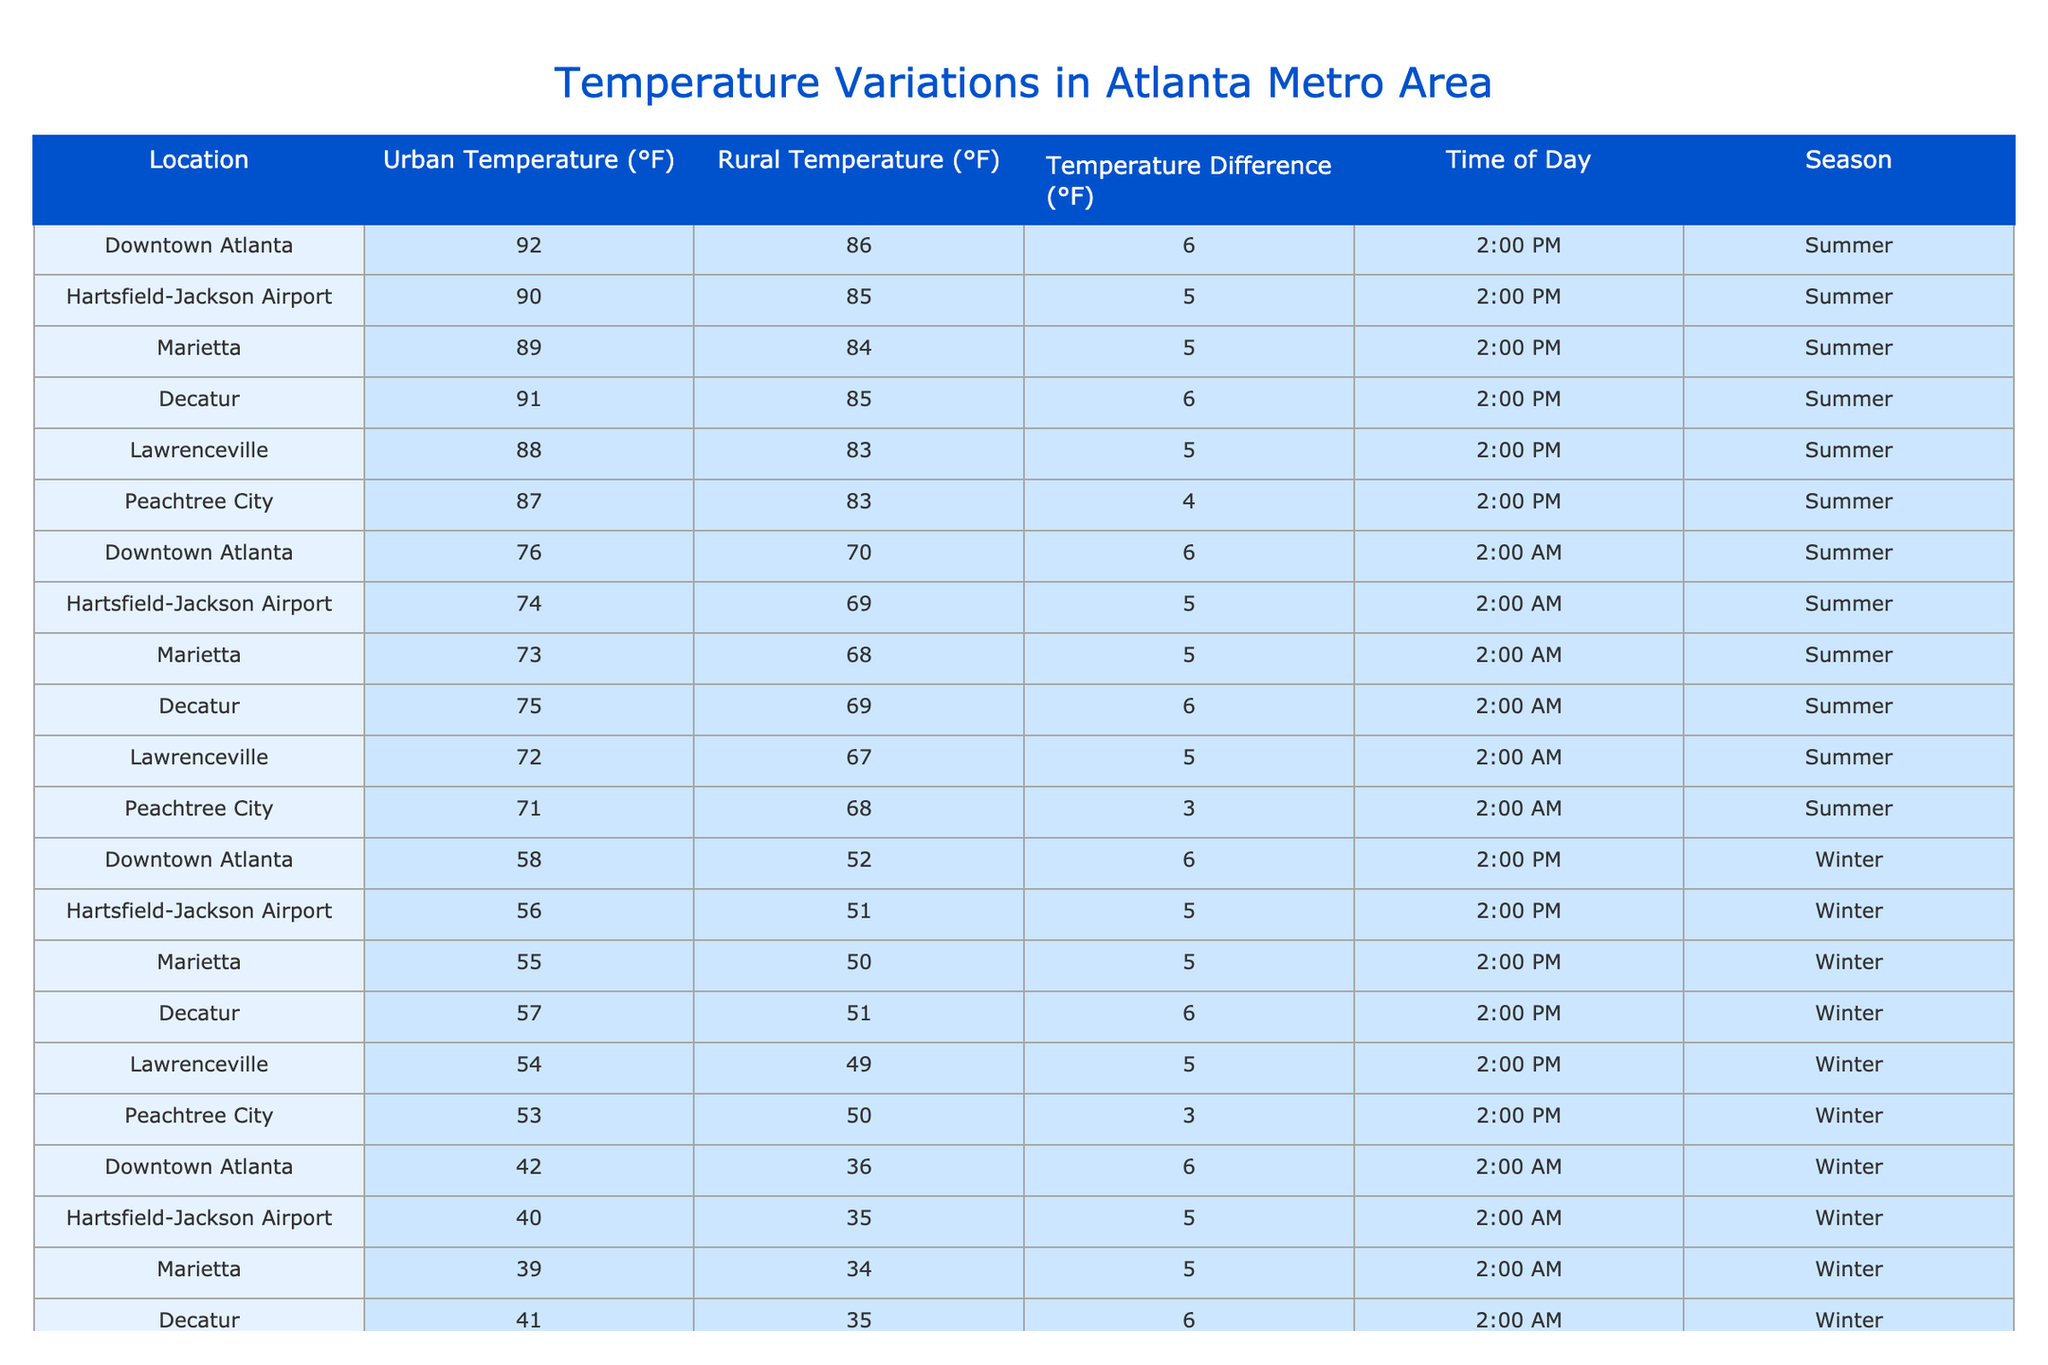What is the urban temperature in Downtown Atlanta during summer at 2:00 PM? The table shows that the urban temperature for Downtown Atlanta is listed as 92°F during summer at 2:00 PM.
Answer: 92°F What is the temperature difference between urban and rural areas in Lawrenceville at 2:00 AM during winter? The temperature difference in Lawrenceville is listed as 5°F between urban (38°F) and rural (33°F) temperatures at 2:00 AM in winter.
Answer: 5°F What is the average urban temperature during summer for all locations mentioned? The urban temperatures during summer for all locations are 92°F, 90°F, 89°F, 91°F, 88°F, and 87°F. The sum is 517°F and there are 6 locations, so the average is 517/6 = 86.17°F.
Answer: 86.17°F Is the rural temperature in Peachtree City warmer in summer or winter at 2:00 PM? In summer, Peachtree City's rural temperature is 83°F at 2:00 PM, while in winter, it is 50°F at the same time. Since 83°F is higher than 50°F, it is warmer in summer.
Answer: Yes Which location has the highest urban temperature at 2:00 AM during winter? The table indicates that at 2:00 AM during winter, Downtown Atlanta has an urban temperature of 42°F, which is higher than other locations (40°F at the airport, 39°F in Marietta, etc.). Thus, Downtown Atlanta has the highest urban temperature.
Answer: Downtown Atlanta What is the total temperature difference between urban and rural temperatures in Marietta for both summer and winter? In summer, the temperature difference in Marietta is 5°F and in winter, it is also 5°F. Adding these gives a total temperature difference of 5°F + 5°F = 10°F.
Answer: 10°F Is the tropical temperature in Decatur warmer than in Hartsfield-Jackson Airport during summer at 2:00 PM? In summer at 2:00 PM, Decatur's urban temperature is 91°F, while Hartsfield-Jackson Airport's is 90°F. Since 91°F is greater than 90°F, Decatur is warmer.
Answer: Yes What is the temperature difference in downtown Atlanta at 2:00 PM compared to 2:00 AM during winter? The urban temperature at 2:00 PM in winter is 58°F and at 2:00 AM is 42°F, leading to a difference of 58°F - 42°F = 16°F.
Answer: 16°F What rural area has the lowest recorded temperature at 2:00 AM during winter? The rural temperatures at 2:00 AM during winter for all locations are 36°F for Downtown Atlanta, 35°F for Hartsfield-Jackson Airport, 34°F for Marietta, and so on. Peachtree City has the lowest rural temperature of 34°F.
Answer: Peachtree City 